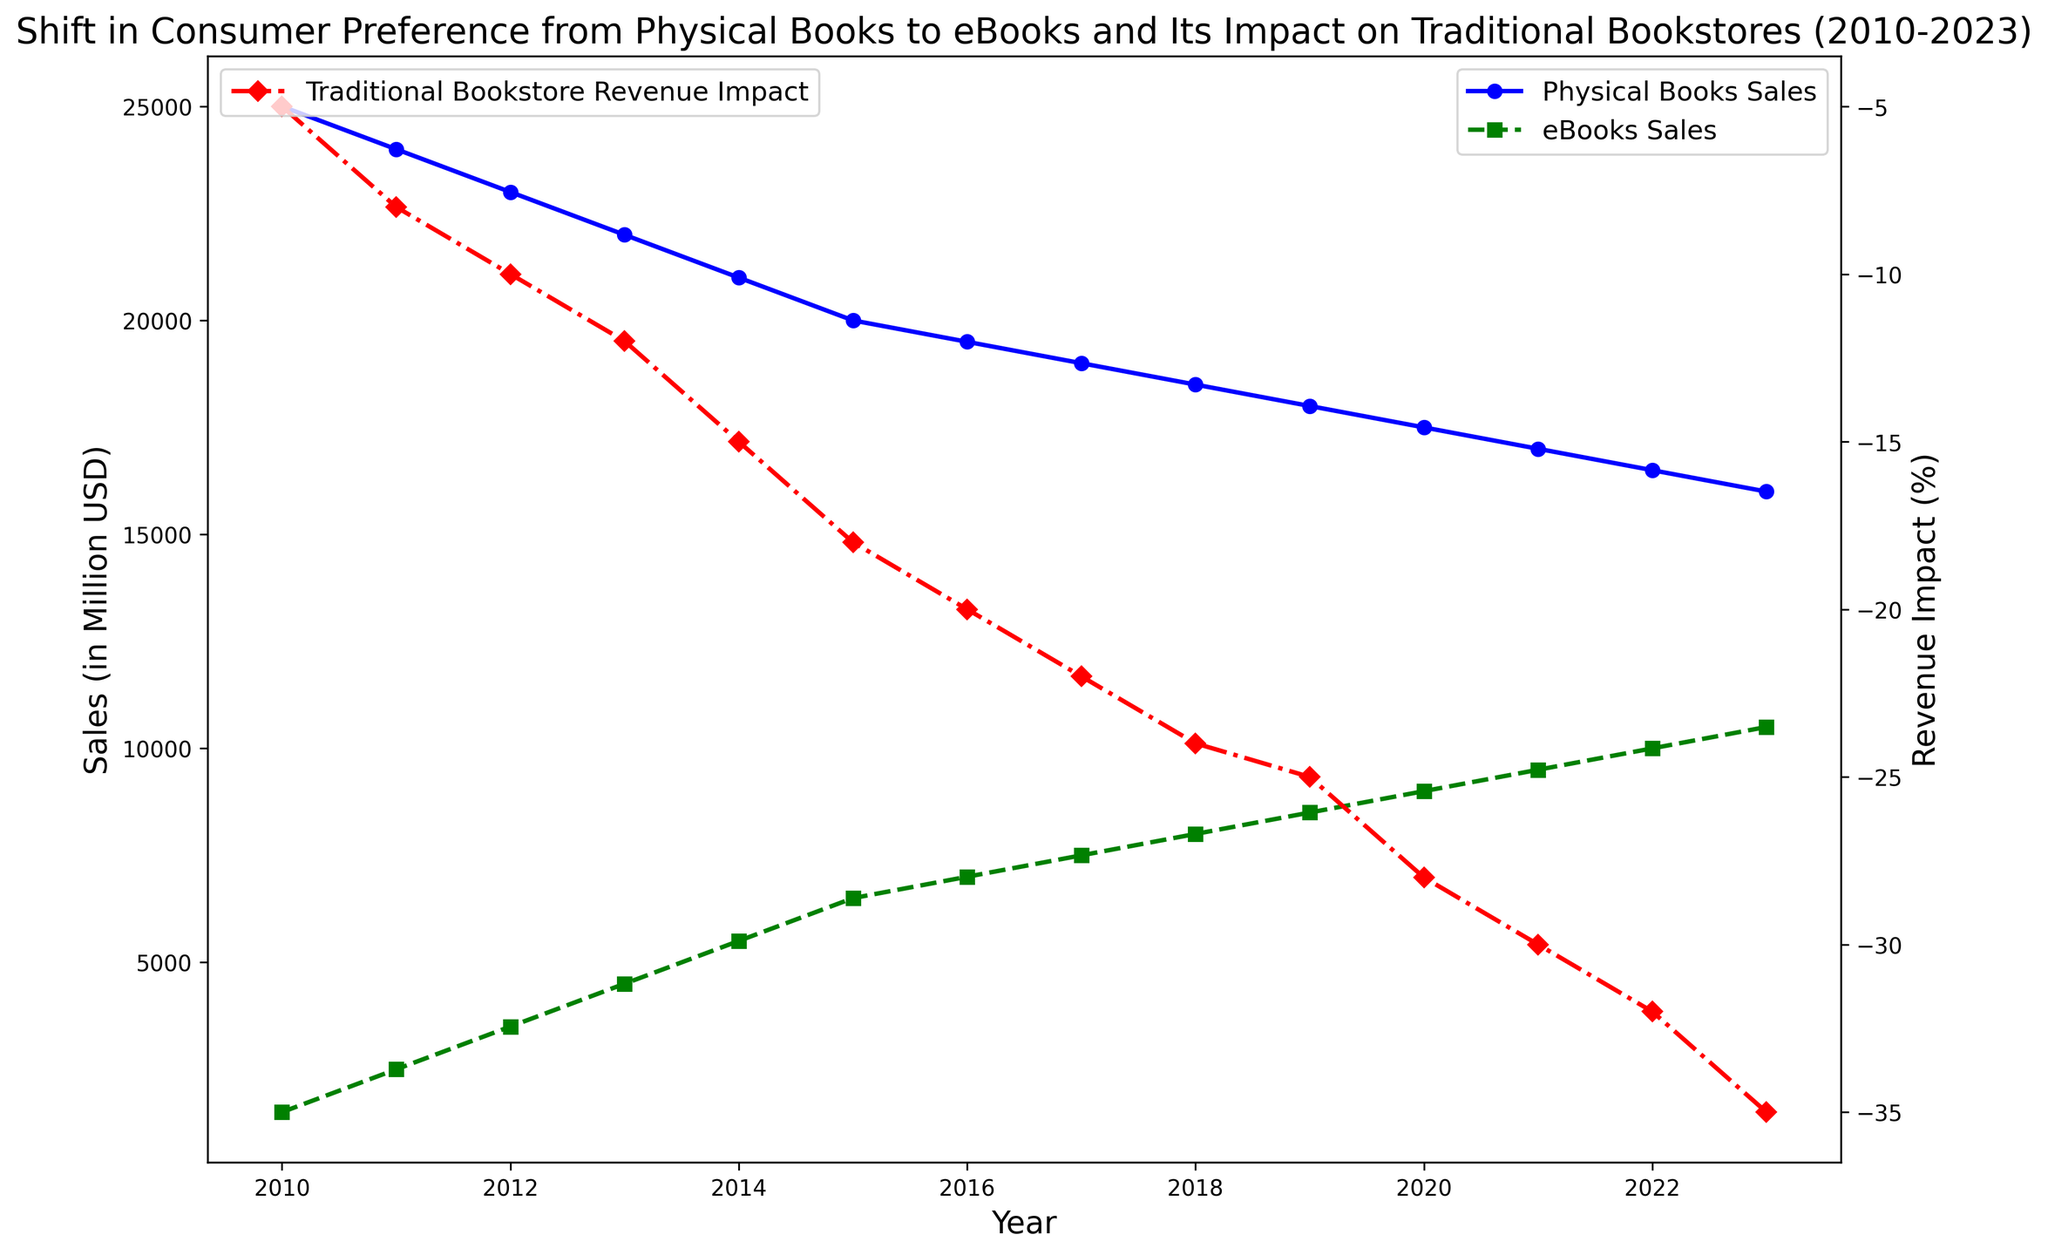What's the difference in sales of physical books between 2010 and 2023? To find the difference, take the sales in 2010 and subtract the sales in 2023: 25000 - 16000 = 9000.
Answer: 9000 million USD Which year saw the highest sales for eBooks? By examining the trend line for eBooks sales, the highest point is in 2023 with 10500 million USD in sales.
Answer: 2023 How did the revenue impact on traditional bookstores change from 2012 to 2015? Look at the revenue impact in 2012 and 2015, and calculate the difference: -18% (2015) - (-10% (2012)) = -8%.
Answer: Decreased by 8% By what percentage did physical book sales decrease from 2010 to 2020? Calculate the percentage decrease: ((25000 - 17500) / 25000) * 100 = 30%.
Answer: 30% Compare the trend of physical book sales and eBooks sales from 2010 to 2023. Which had a more rapid change? Both trends decrease or increase over time, but eBooks sales (from 1500 to 10500) increased rapidly compared to physical books sales (from 25000 to 16000).
Answer: eBooks sales had a more rapid change What was the average revenue impact on traditional bookstores from 2010 to 2023? Average is calculated by summing the revenue impacts and dividing by the number of years, i.e., (-5 - 8 - 10 - 12 - 15 - 18 - 20 - 22 - 24 - 25 - 28 - 30 - 32 - 35) / 14 = -20%.
Answer: -20% In which year did the revenue impact on traditional bookstores reach -20%? By checking the secondary y-axis line, the year when revenue impact was -20% is 2016.
Answer: 2016 Between which consecutive years did physical books sales show the largest drop? The largest yearly loss is between 2014 and 2015: 21000 (2014) - 20000 (2015) = 1000.
Answer: 2014 to 2015 From 2010 to 2023, how much did the eBooks sales increase on average per year? Calculate the increase per year: (10500 - 1500) / 13 = 692.31 million USD/year.
Answer: 692.31 million USD/year 